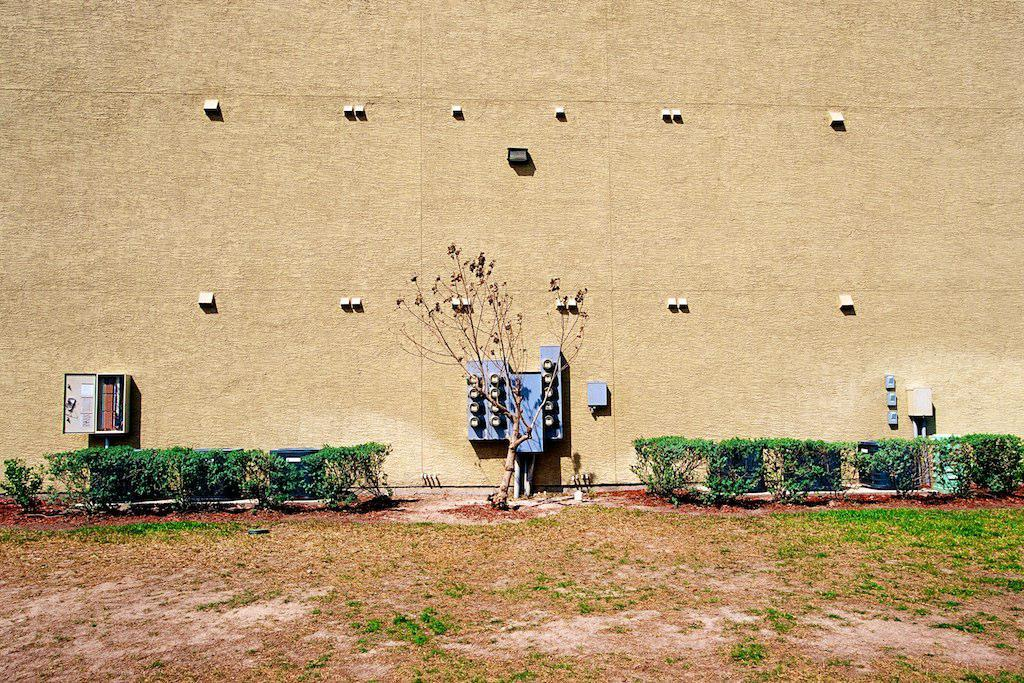What is present on the wall in the image? There are lights, electrical boxes, and other objects on the wall in the image. What type of plants can be seen in the image? There are plants and a tree in the image. Where are the plants and tree located? They are in a garden in the image. How much milk is being poured into the pot in the image? There is no pot or milk present in the image. Is there any dust visible on the plants in the image? The image does not show any dust on the plants; it only shows the plants and a tree in a garden. 